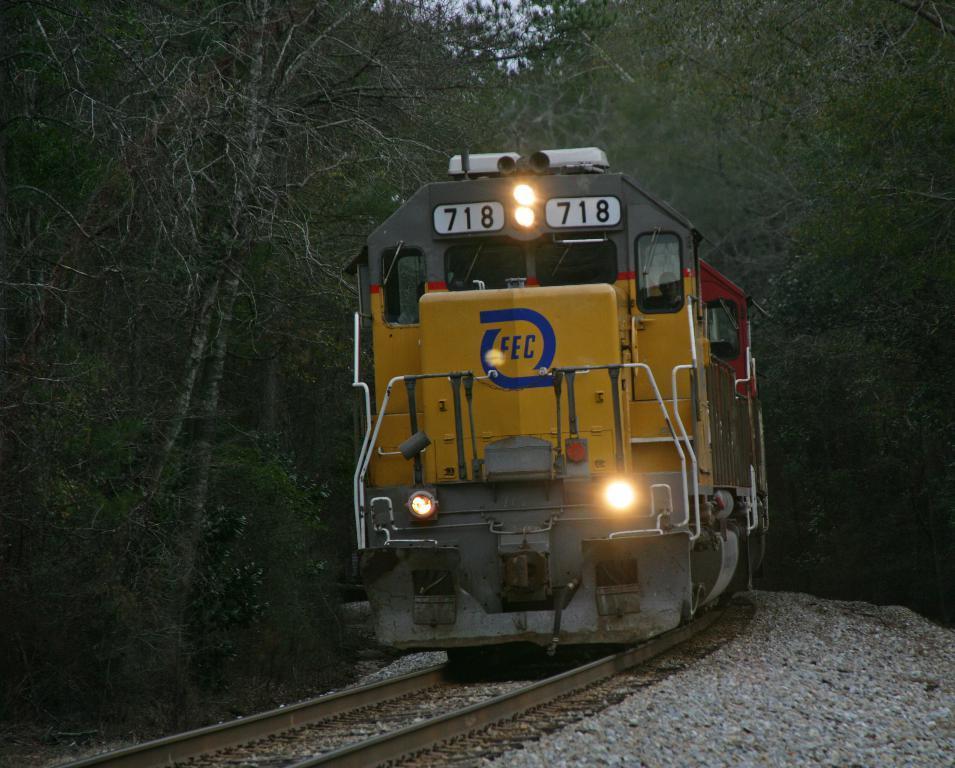Please provide a concise description of this image. We can see train on track and stones. In the background we can see trees and sky. 